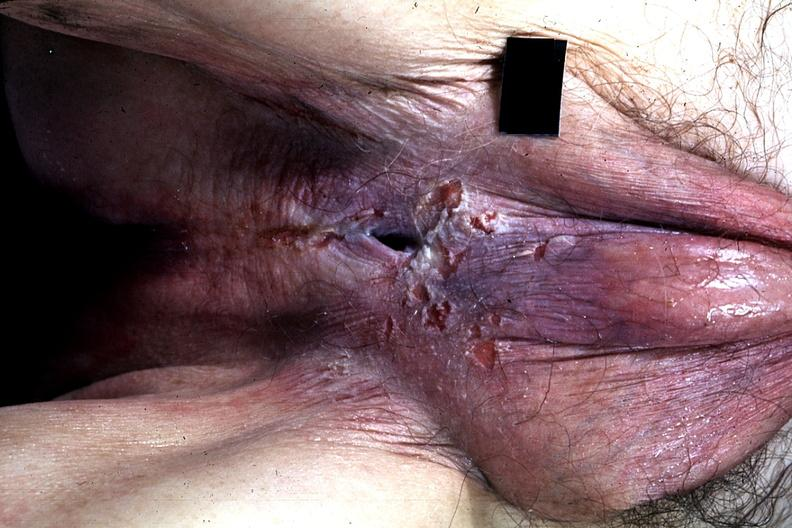s hypospadias present?
Answer the question using a single word or phrase. Yes 